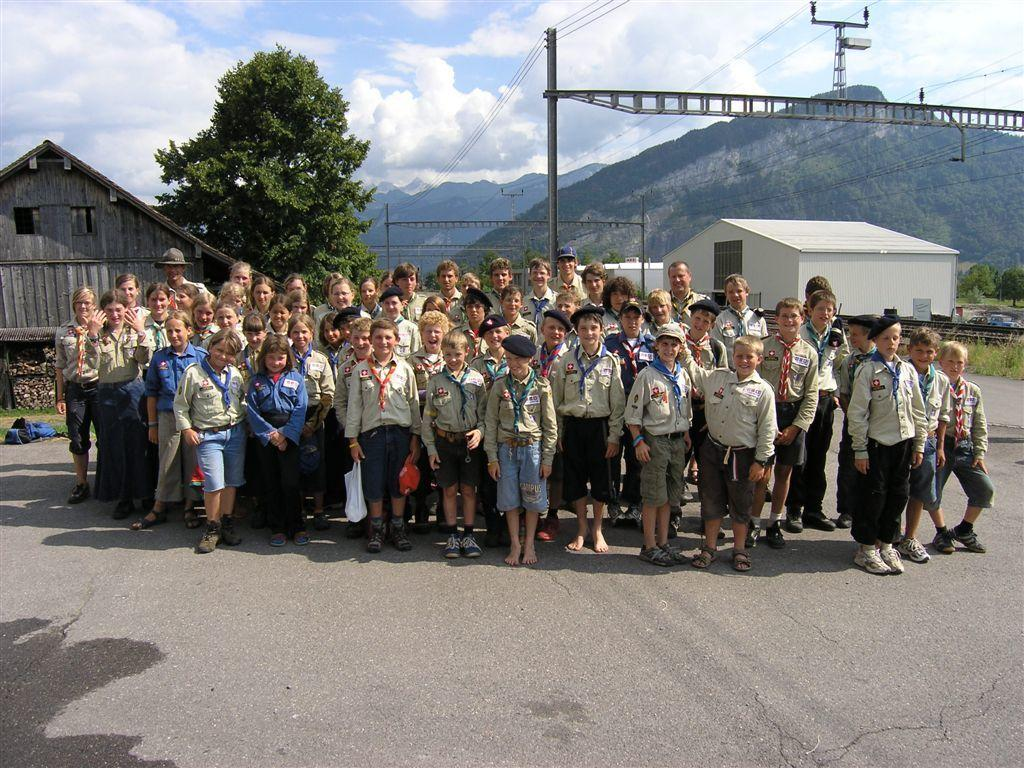How many people are in the image? There is a group of people in the image. What are the people doing in the image? The people are standing together. What are the people wearing in the image? The people are wearing uniforms. What can be seen in the background of the image? There are mountains, a tree, and a shed visible in the background of the image. What type of growth can be seen on the people's minds in the image? There is no indication of any growth on the people's minds in the image, as it is a photograph of people standing together. 